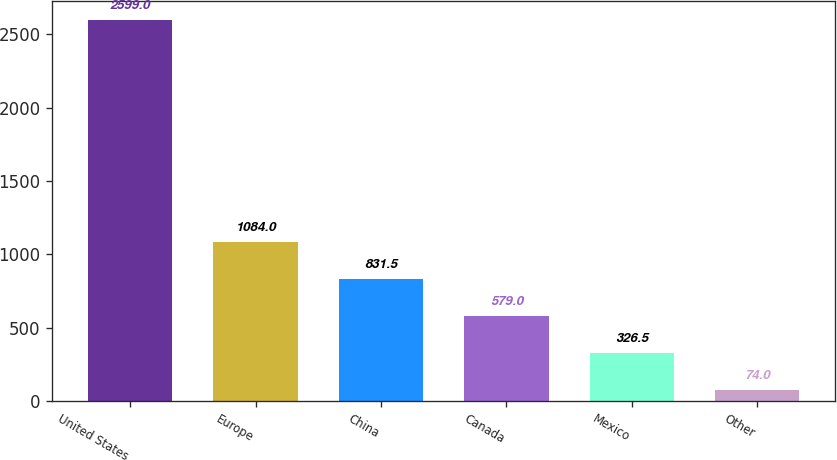Convert chart. <chart><loc_0><loc_0><loc_500><loc_500><bar_chart><fcel>United States<fcel>Europe<fcel>China<fcel>Canada<fcel>Mexico<fcel>Other<nl><fcel>2599<fcel>1084<fcel>831.5<fcel>579<fcel>326.5<fcel>74<nl></chart> 